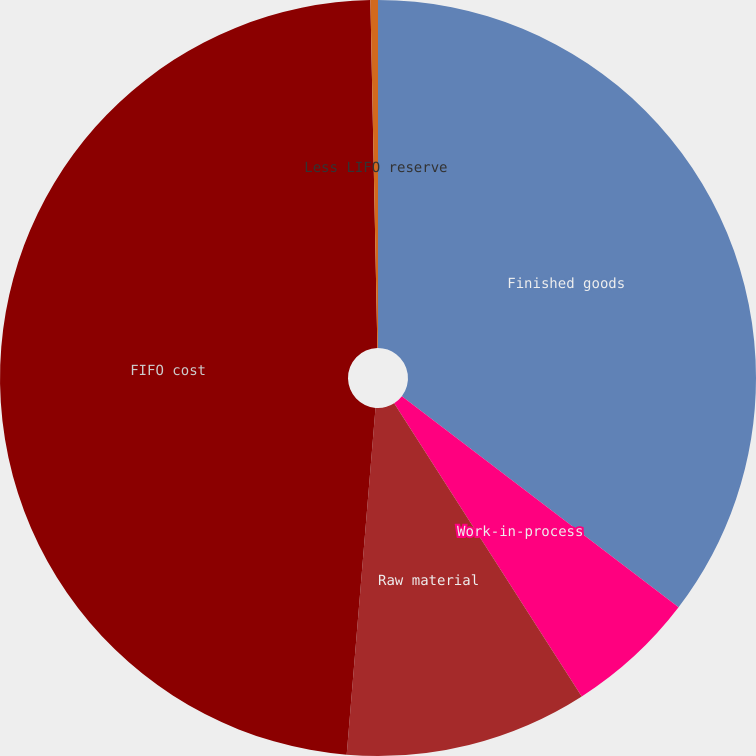<chart> <loc_0><loc_0><loc_500><loc_500><pie_chart><fcel>Finished goods<fcel>Work-in-process<fcel>Raw material<fcel>FIFO cost<fcel>Less LIFO reserve<nl><fcel>35.37%<fcel>5.57%<fcel>10.38%<fcel>48.36%<fcel>0.32%<nl></chart> 